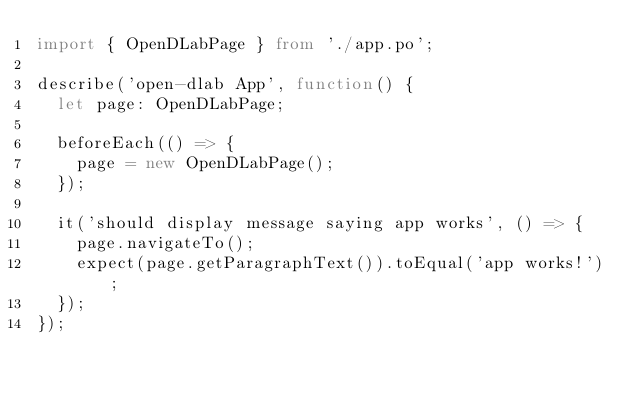<code> <loc_0><loc_0><loc_500><loc_500><_TypeScript_>import { OpenDLabPage } from './app.po';

describe('open-dlab App', function() {
  let page: OpenDLabPage;

  beforeEach(() => {
    page = new OpenDLabPage();
  });

  it('should display message saying app works', () => {
    page.navigateTo();
    expect(page.getParagraphText()).toEqual('app works!');
  });
});
</code> 